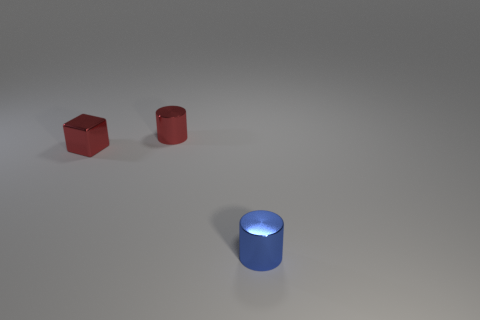What is the size of the cylinder that is the same color as the small metal cube?
Provide a short and direct response. Small. Are there fewer tiny blocks that are behind the red block than cubes right of the blue cylinder?
Give a very brief answer. No. How many gray objects are cubes or tiny cylinders?
Your response must be concise. 0. Are there an equal number of red blocks right of the small red block and small metal objects?
Make the answer very short. No. What number of things are either red metallic cylinders or cylinders to the left of the blue shiny thing?
Your answer should be very brief. 1. Is there a big cyan cube that has the same material as the small blue object?
Make the answer very short. No. The other shiny object that is the same shape as the blue object is what color?
Your answer should be compact. Red. Is the material of the red cylinder the same as the blue cylinder that is in front of the small red block?
Offer a terse response. Yes. The tiny red object in front of the tiny red thing right of the cube is what shape?
Offer a terse response. Cube. There is a metal cylinder left of the blue object; does it have the same size as the small blue thing?
Offer a very short reply. Yes. 